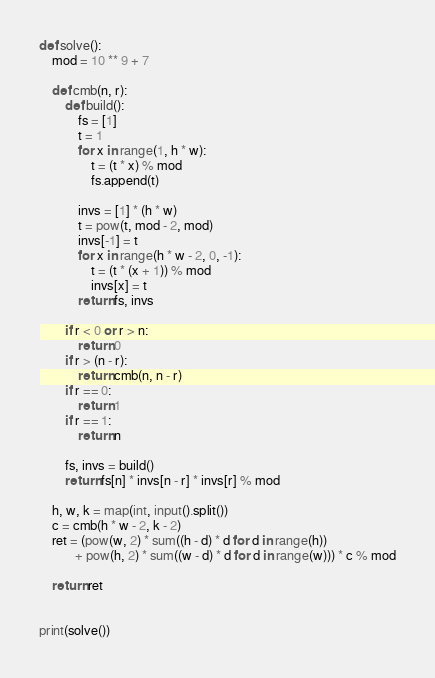<code> <loc_0><loc_0><loc_500><loc_500><_Python_>def solve():
    mod = 10 ** 9 + 7

    def cmb(n, r):
        def build():
            fs = [1]
            t = 1
            for x in range(1, h * w):
                t = (t * x) % mod
                fs.append(t)

            invs = [1] * (h * w)
            t = pow(t, mod - 2, mod)
            invs[-1] = t
            for x in range(h * w - 2, 0, -1):
                t = (t * (x + 1)) % mod
                invs[x] = t
            return fs, invs

        if r < 0 or r > n:
            return 0
        if r > (n - r):
            return cmb(n, n - r)
        if r == 0:
            return 1
        if r == 1:
            return n

        fs, invs = build()
        return fs[n] * invs[n - r] * invs[r] % mod

    h, w, k = map(int, input().split())
    c = cmb(h * w - 2, k - 2)
    ret = (pow(w, 2) * sum((h - d) * d for d in range(h))
           + pow(h, 2) * sum((w - d) * d for d in range(w))) * c % mod

    return ret


print(solve())</code> 